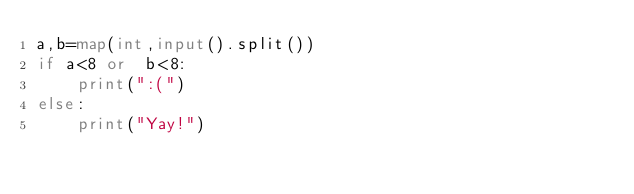Convert code to text. <code><loc_0><loc_0><loc_500><loc_500><_Python_>a,b=map(int,input().split())
if a<8 or  b<8:
    print(":(")
else:
    print("Yay!")</code> 